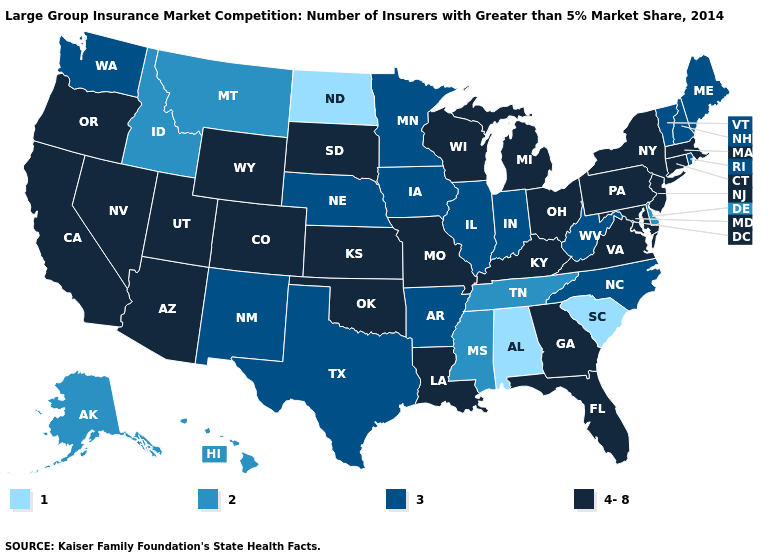Name the states that have a value in the range 4-8?
Be succinct. Arizona, California, Colorado, Connecticut, Florida, Georgia, Kansas, Kentucky, Louisiana, Maryland, Massachusetts, Michigan, Missouri, Nevada, New Jersey, New York, Ohio, Oklahoma, Oregon, Pennsylvania, South Dakota, Utah, Virginia, Wisconsin, Wyoming. How many symbols are there in the legend?
Be succinct. 4. Which states have the lowest value in the USA?
Quick response, please. Alabama, North Dakota, South Carolina. What is the value of South Dakota?
Answer briefly. 4-8. Among the states that border Connecticut , which have the lowest value?
Be succinct. Rhode Island. What is the value of Washington?
Give a very brief answer. 3. Name the states that have a value in the range 2?
Short answer required. Alaska, Delaware, Hawaii, Idaho, Mississippi, Montana, Tennessee. Which states have the lowest value in the South?
Write a very short answer. Alabama, South Carolina. Which states hav the highest value in the West?
Keep it brief. Arizona, California, Colorado, Nevada, Oregon, Utah, Wyoming. What is the value of Florida?
Short answer required. 4-8. What is the lowest value in states that border Idaho?
Keep it brief. 2. Among the states that border Nebraska , does Iowa have the highest value?
Short answer required. No. What is the value of New Jersey?
Quick response, please. 4-8. What is the value of Missouri?
Give a very brief answer. 4-8. Does Iowa have a higher value than Hawaii?
Be succinct. Yes. 